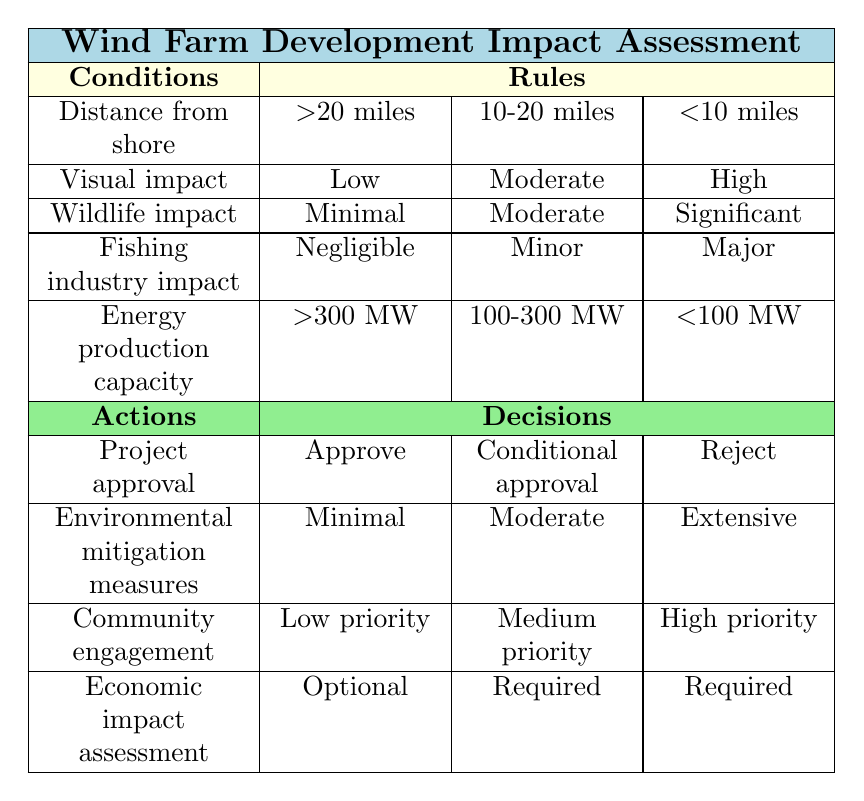What project approval results from a distance from shore greater than 20 miles and a visual impact of low? According to the table, under the condition where the distance from shore is greater than 20 miles and the visual impact is low, the project approval result is "Approve."
Answer: Approve Is environmental mitigation minimal for projects located 10-20 miles from shore with a moderate visual impact? The table shows that for projects located 10-20 miles from shore with a moderate visual impact, the environmental mitigation measures are classified as "Moderate," not minimal.
Answer: No What is the community engagement priority for projects less than 10 miles from shore with significant wildlife impact? The table indicates that for projects less than 10 miles from shore and with significant wildlife impact, the community engagement priority is labeled as "High priority."
Answer: High priority What is the economic impact assessment status for projects that are less than 10 miles from shore, have a high visual impact, significant wildlife impact, and major fishing industry impact? Analyzing the table, for projects that fulfill these conditions (less than 10 miles from shore, high visual impact, significant wildlife impact, and major fishing industry impact), the economic impact assessment is "Required."
Answer: Required If we combine the distances from shore and fishing industry impacts, how many conditions lead to the rejection of a project? The only rule that leads to the rejection of a project occurs when it is less than 10 miles from shore with a high visual impact, significant wildlife impact, and a major fishing industry impact. Thus, there is one such condition that leads to rejection.
Answer: 1 For a project with a minimal wildlife impact, what is the highest energy production capacity that can still receive approval? The table indicates that projects with a wildlife impact categorized as minimal and a distance from shore greater than 20 miles, along with an energy production capacity of greater than 300 MW, can receive approval. This sets the energy production capacity at the higher end above 300 MW.
Answer: >300 MW How does the fishing industry impact compare between projects that are 10-20 miles from shore and have moderate wildlife impact versus projects less than 10 miles with major wildlife impact? The comparison reveals that for projects 10-20 miles from shore and with moderate wildlife impact, the fishing industry impact is classified as "Minor." For projects less than 10 miles, with major wildlife impact, the fishing industry impact is "Major," indicating a higher concern for the latter.
Answer: Minor vs Major Is it true that all projects greater than 20 miles from shore can have conditional approval? Evaluating the conditions in the table, only those distances greater than 20 miles with specific criteria (low visual impact, minimal wildlife impact, negligible fishing industry impact, and energy production above 300 MW) receive an "Approve" designation. Thus, not all greater than 20 miles automatically receive conditional approval.
Answer: No 